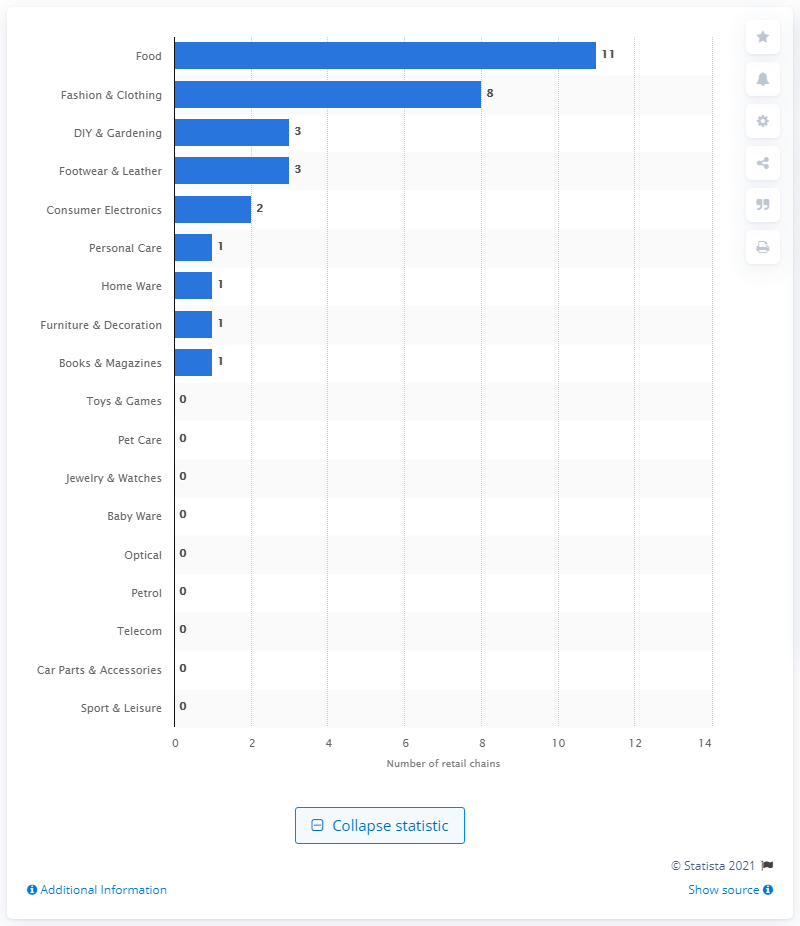List a handful of essential elements in this visual. In the year 2020, the leading sector in Belarus was the food industry. 